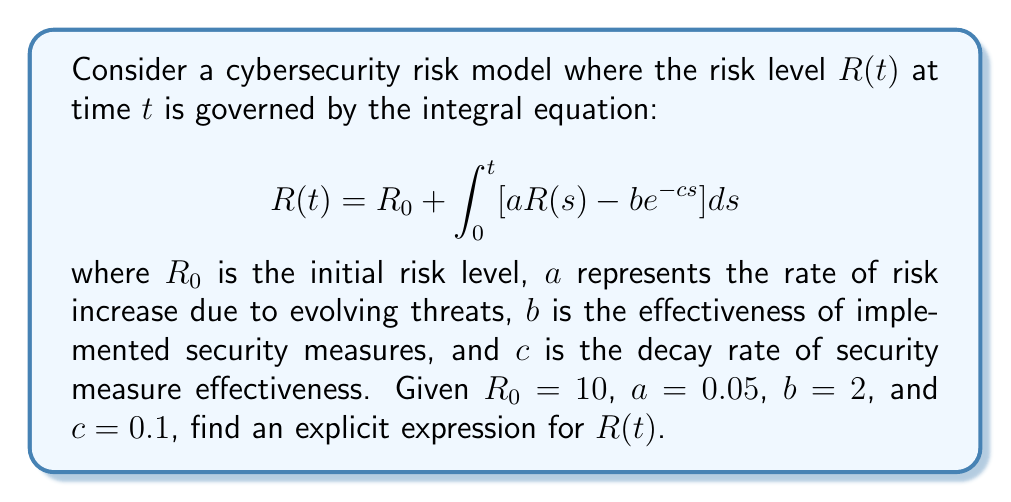Help me with this question. To solve this integral equation, we'll follow these steps:

1) First, we differentiate both sides of the equation with respect to $t$:

   $$\frac{dR}{dt} = a R(t) - b e^{-ct}$$

2) This is now a first-order linear differential equation. We can solve it using the integrating factor method.

3) The integrating factor is $e^{-at}$. Multiplying both sides by this:

   $$e^{-at} \frac{dR}{dt} - a e^{-at} R(t) = -b e^{-at-ct}$$

4) The left side is now the derivative of $e^{-at}R(t)$:

   $$\frac{d}{dt}(e^{-at}R(t)) = -b e^{-at-ct}$$

5) Integrating both sides:

   $$e^{-at}R(t) = \frac{b}{a-c}e^{-at-ct} + C$$

6) Solving for $R(t)$:

   $$R(t) = \frac{b}{a-c}e^{-ct} + Ce^{at}$$

7) To find $C$, we use the initial condition $R(0) = R_0 = 10$:

   $$10 = \frac{b}{a-c} + C$$
   $$C = 10 - \frac{b}{a-c}$$

8) Substituting the values $a = 0.05$, $b = 2$, and $c = 0.1$:

   $$R(t) = \frac{2}{0.05-0.1}e^{-0.1t} + (10 - \frac{2}{0.05-0.1})e^{0.05t}$$

9) Simplifying:

   $$R(t) = -40e^{-0.1t} + 50e^{0.05t}$$

This is the explicit expression for $R(t)$.
Answer: $R(t) = -40e^{-0.1t} + 50e^{0.05t}$ 